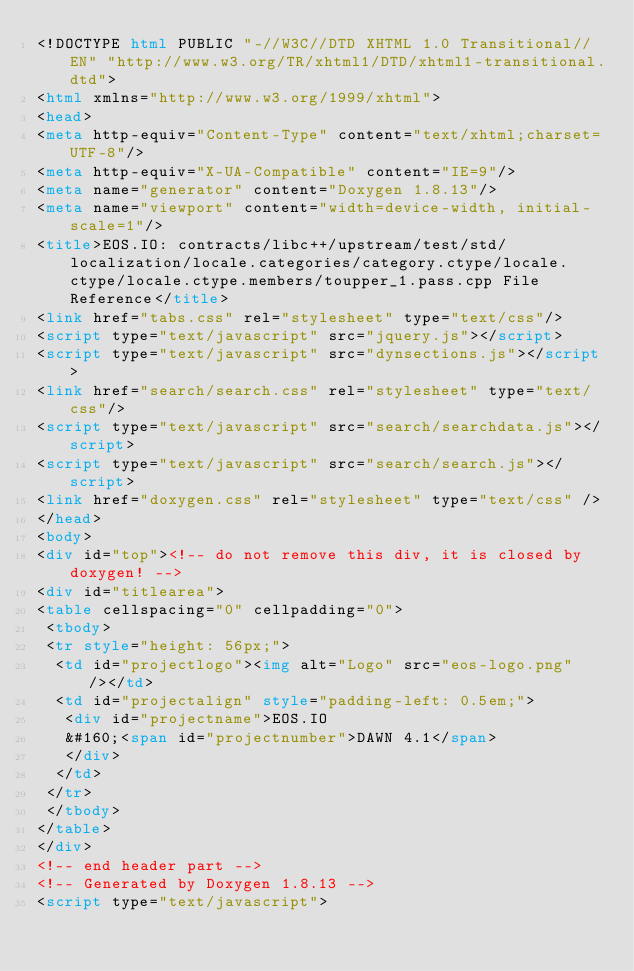Convert code to text. <code><loc_0><loc_0><loc_500><loc_500><_HTML_><!DOCTYPE html PUBLIC "-//W3C//DTD XHTML 1.0 Transitional//EN" "http://www.w3.org/TR/xhtml1/DTD/xhtml1-transitional.dtd">
<html xmlns="http://www.w3.org/1999/xhtml">
<head>
<meta http-equiv="Content-Type" content="text/xhtml;charset=UTF-8"/>
<meta http-equiv="X-UA-Compatible" content="IE=9"/>
<meta name="generator" content="Doxygen 1.8.13"/>
<meta name="viewport" content="width=device-width, initial-scale=1"/>
<title>EOS.IO: contracts/libc++/upstream/test/std/localization/locale.categories/category.ctype/locale.ctype/locale.ctype.members/toupper_1.pass.cpp File Reference</title>
<link href="tabs.css" rel="stylesheet" type="text/css"/>
<script type="text/javascript" src="jquery.js"></script>
<script type="text/javascript" src="dynsections.js"></script>
<link href="search/search.css" rel="stylesheet" type="text/css"/>
<script type="text/javascript" src="search/searchdata.js"></script>
<script type="text/javascript" src="search/search.js"></script>
<link href="doxygen.css" rel="stylesheet" type="text/css" />
</head>
<body>
<div id="top"><!-- do not remove this div, it is closed by doxygen! -->
<div id="titlearea">
<table cellspacing="0" cellpadding="0">
 <tbody>
 <tr style="height: 56px;">
  <td id="projectlogo"><img alt="Logo" src="eos-logo.png"/></td>
  <td id="projectalign" style="padding-left: 0.5em;">
   <div id="projectname">EOS.IO
   &#160;<span id="projectnumber">DAWN 4.1</span>
   </div>
  </td>
 </tr>
 </tbody>
</table>
</div>
<!-- end header part -->
<!-- Generated by Doxygen 1.8.13 -->
<script type="text/javascript"></code> 